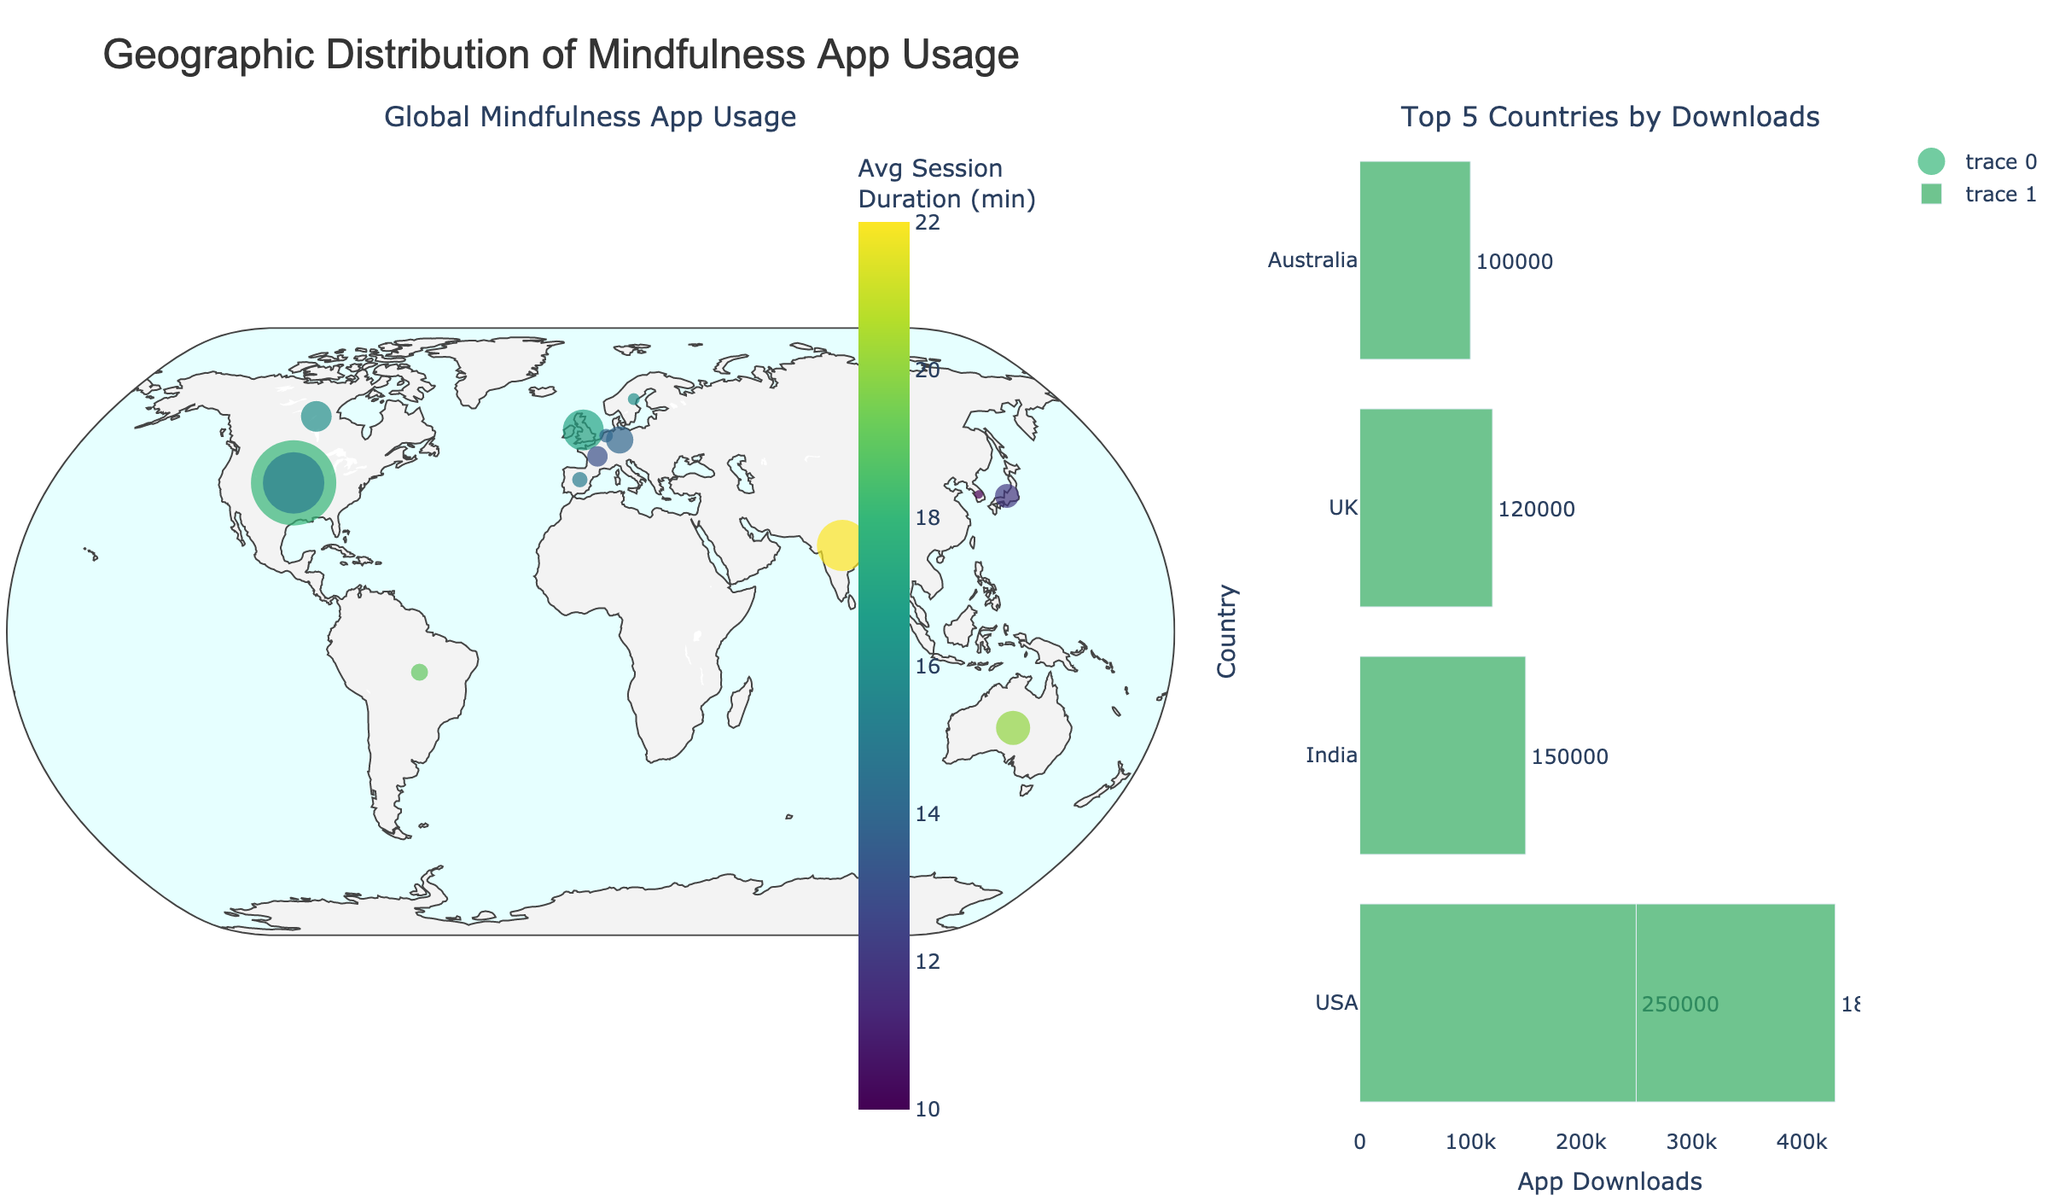Which country has the highest number of app downloads? By looking at the bar chart, the longest bar represents the country with the highest number of app downloads. The longest bar corresponds to the USA.
Answer: USA What is the average session duration in Maharashtra, India? Check the information box that appears when hovering over Maharashtra on the map. The text includes 'Avg Session: 22 min'.
Answer: 22 minutes Which region has more daily active users, Tokyo or Île-de-France? The data above the markers shown in Tokyo and Île-de-France on the map will show their daily active users. Tokyo has 20,000 while Île-de-France has 18,000.
Answer: Tokyo Which country has the second smallest number of daily active users? From the map and bar chart, identify the second shortest bar in the daily active users category, which corresponds to Seoul, South Korea with 6,000 daily active users.
Answer: South Korea What is the total number of daily active users from the regions in Australia and Canada? Australia (New South Wales) has 35,000 daily active users and Canada (Ontario) has 30,000 daily active users. Sum them up: 35,000 + 30,000 = 65,000
Answer: 65,000 How does the average session duration in São Paulo compare to that in New York? Hover over São Paulo and New York on the map to view the average session duration. São Paulo has 19 minutes, while New York has 15 minutes. 19 is greater than 15.
Answer: São Paulo > New York What is the median value of app downloads among the top 5 countries? The top 5 countries by downloads are USA (250,000), New York (180,000), Maharashtra (150,000), England (120,000), and New South Wales (100,000). Arrange these numbers and find the median value, which is 150,000 (Maharashtra).
Answer: 150,000 Which country in Europe has the largest average session duration? Look at each European country (UK, Germany, France, Spain, Netherlands, Sweden) on the map and compare the average session durations shown in the hover boxes. The UK has the highest with 17 minutes.
Answer: UK 